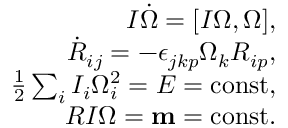Convert formula to latex. <formula><loc_0><loc_0><loc_500><loc_500>\begin{array} { r } { I \dot { \boldsymbol \Omega } = [ I { \boldsymbol \Omega } , { \boldsymbol \Omega } ] , } \\ { \dot { R } _ { i j } = - \epsilon _ { j k p } \Omega _ { k } R _ { i p } , } \\ { \frac { 1 } { 2 } \sum _ { i } I _ { i } \Omega _ { i } ^ { 2 } = E = c o n s t , } \\ { R I { \boldsymbol \Omega } = { m } = c o n s t . } \end{array}</formula> 